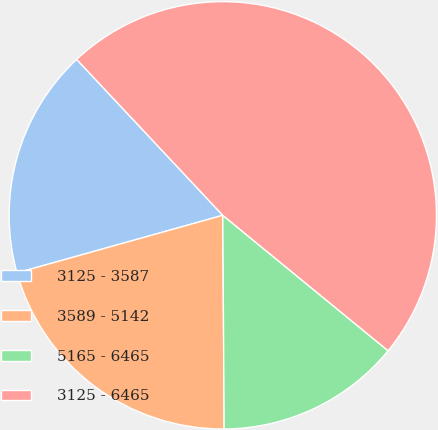<chart> <loc_0><loc_0><loc_500><loc_500><pie_chart><fcel>3125 - 3587<fcel>3589 - 5142<fcel>5165 - 6465<fcel>3125 - 6465<nl><fcel>17.36%<fcel>20.76%<fcel>13.97%<fcel>47.91%<nl></chart> 